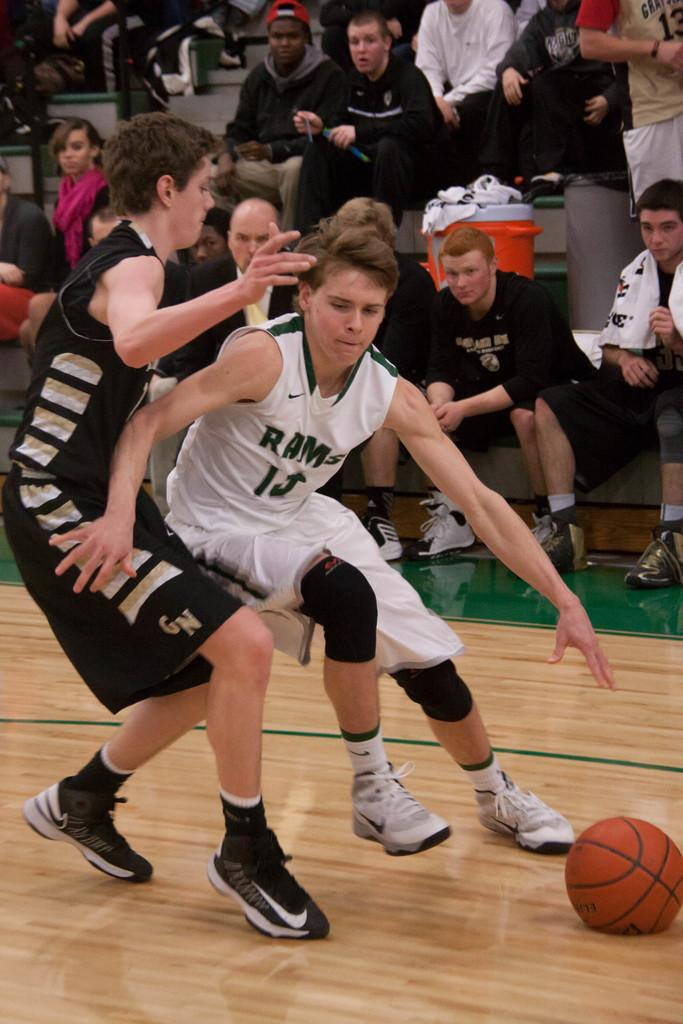What are the two men in the image doing? The two men in the image are running. What object is on the surface in the image? There is a ball on the surface in the image. What can be seen in the background of the image? There are people and a bin visible in the background of the image. What type of letter is being delivered to the men in the image? There is no letter present in the image; it only features two men running and a ball on the surface. 